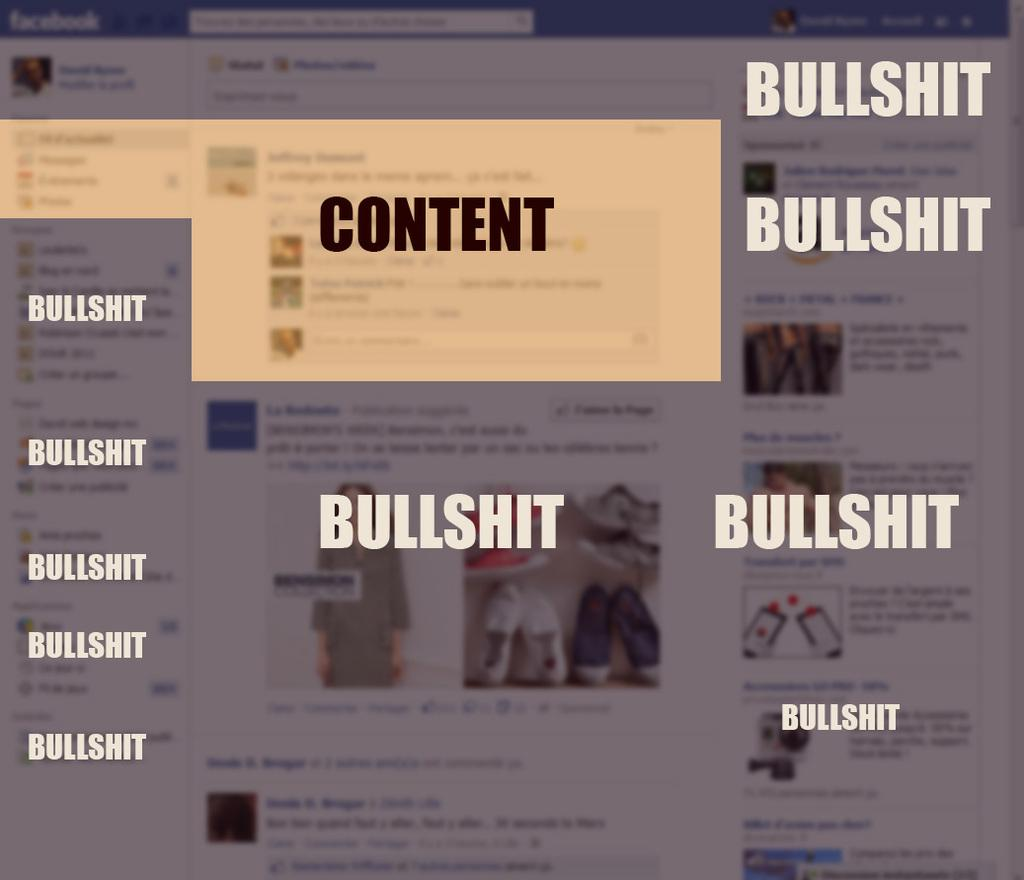What can be seen on the screen in the image? There are images on the screen in the image. What else is visible in the image besides the screen? There is text visible in the image. How many circles can be seen in the image? There is no circle present in the image. Is the person in the image sleeping? There is no person present in the image, so it cannot be determined if someone is sleeping. 